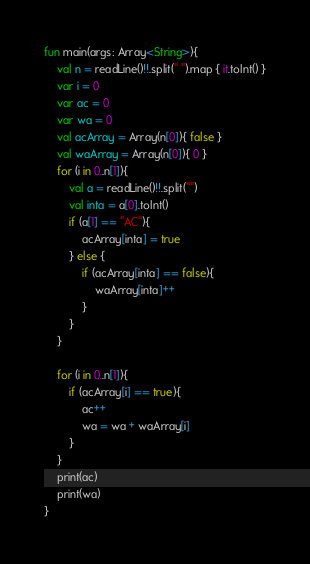<code> <loc_0><loc_0><loc_500><loc_500><_Kotlin_>fun main(args: Array<String>){
    val n = readLine()!!.split(" ").map { it.toInt() }
    var i = 0
    var ac = 0
    var wa = 0
    val acArray = Array(n[0]){ false }
    val waArray = Array(n[0]){ 0 }
    for (i in 0..n[1]){
        val a = readLine()!!.split("")
        val inta = a[0].toInt()
        if (a[1] == "AC"){
            acArray[inta] = true
        } else {
            if (acArray[inta] == false){
                waArray[inta]++
            }
        }
    }

    for (i in 0..n[1]){
        if (acArray[i] == true){
            ac++
            wa = wa + waArray[i]
        }
    }
    print(ac)
    print(wa)
}</code> 